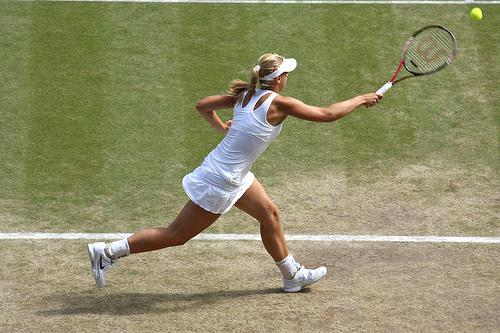Question: what color is the woman's hair?
Choices:
A. Blonde.
B. Brown.
C. Black.
D. Red.
Answer with the letter. Answer: A Question: what color are the woman's clothes?
Choices:
A. Pink.
B. White.
C. Yellow.
D. Teal.
Answer with the letter. Answer: B Question: what is the woman playing?
Choices:
A. Baseball.
B. Golf.
C. Basketball.
D. Tennis.
Answer with the letter. Answer: D Question: what brand is the tennis racket?
Choices:
A. Wilson.
B. Head.
C. Nike.
D. Prince.
Answer with the letter. Answer: A Question: where was the picture taken?
Choices:
A. At a tennis court.
B. On a golf course.
C. At a boxing match.
D. On a basketball court.
Answer with the letter. Answer: A Question: what time of day was the picture taken?
Choices:
A. Midnight.
B. Dawn.
C. Dusk.
D. Midday.
Answer with the letter. Answer: D Question: why is there a white line in the picture?
Choices:
A. To keep cars in line.
B. It is a boundary in the tennis court.
C. To mark the parking area.
D. To provide directions.
Answer with the letter. Answer: B Question: who is in the picture?
Choices:
A. A golfer.
B. A tennis player.
C. A hockey player.
D. A baseball player.
Answer with the letter. Answer: B 